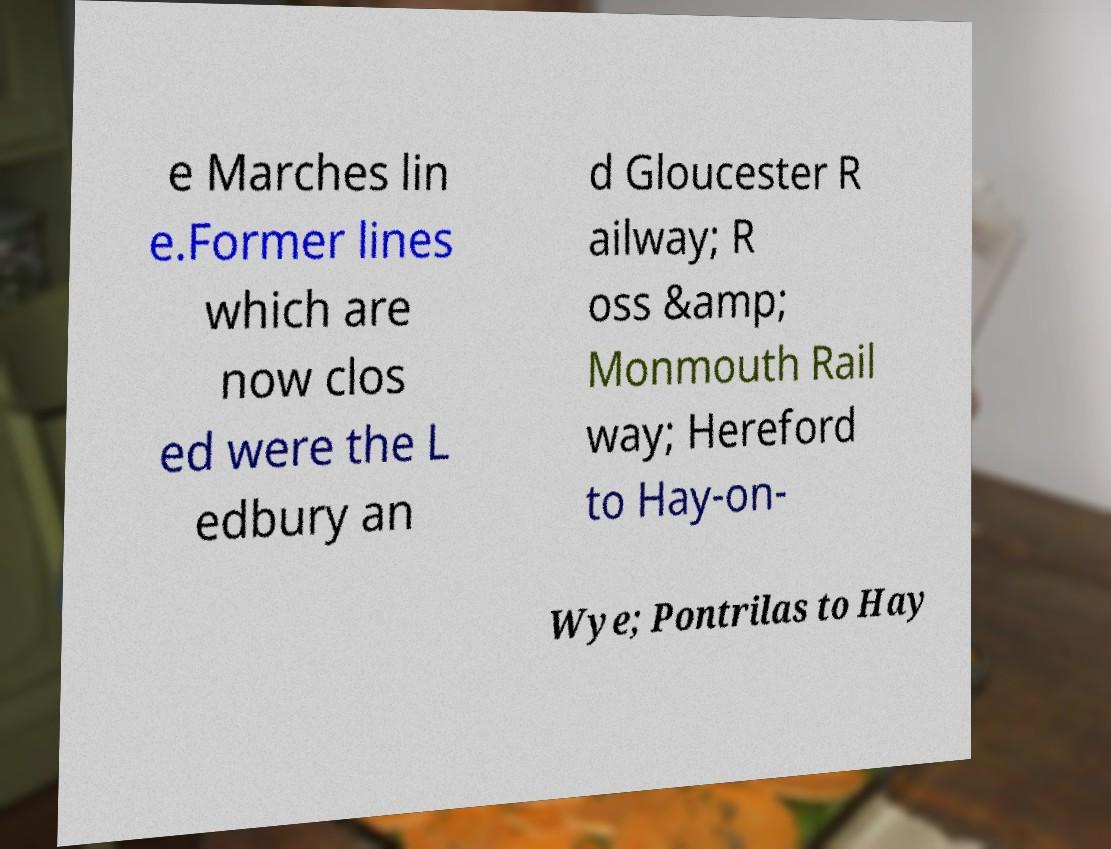Could you assist in decoding the text presented in this image and type it out clearly? e Marches lin e.Former lines which are now clos ed were the L edbury an d Gloucester R ailway; R oss &amp; Monmouth Rail way; Hereford to Hay-on- Wye; Pontrilas to Hay 